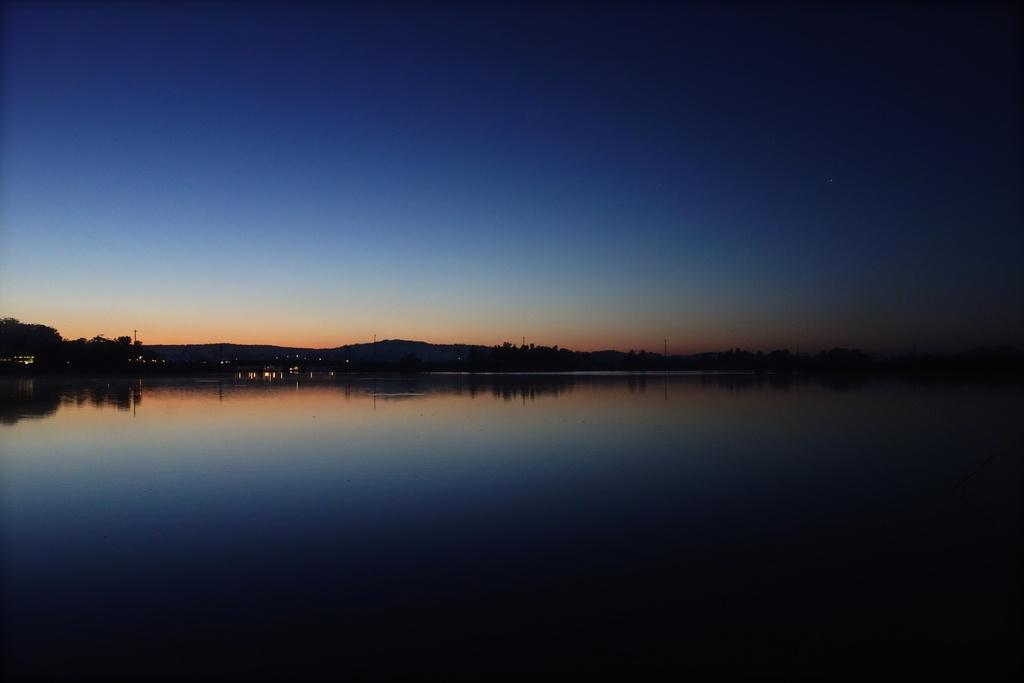What is the main feature of the image? The main feature of the image is water. What other natural elements can be seen in the image? There are mountains in the image. What is visible at the top of the image? The sky is visible at the top of the image. What can be observed on the surface of the water? The reflection of the sky and mountains can be seen on the water. What type of stew is being cooked in the image? There is no stew present in the image; it features water, mountains, and the sky. What position does the idea hold in the image? There is no idea present in the image; it is a natural scene with water, mountains, and the sky. 